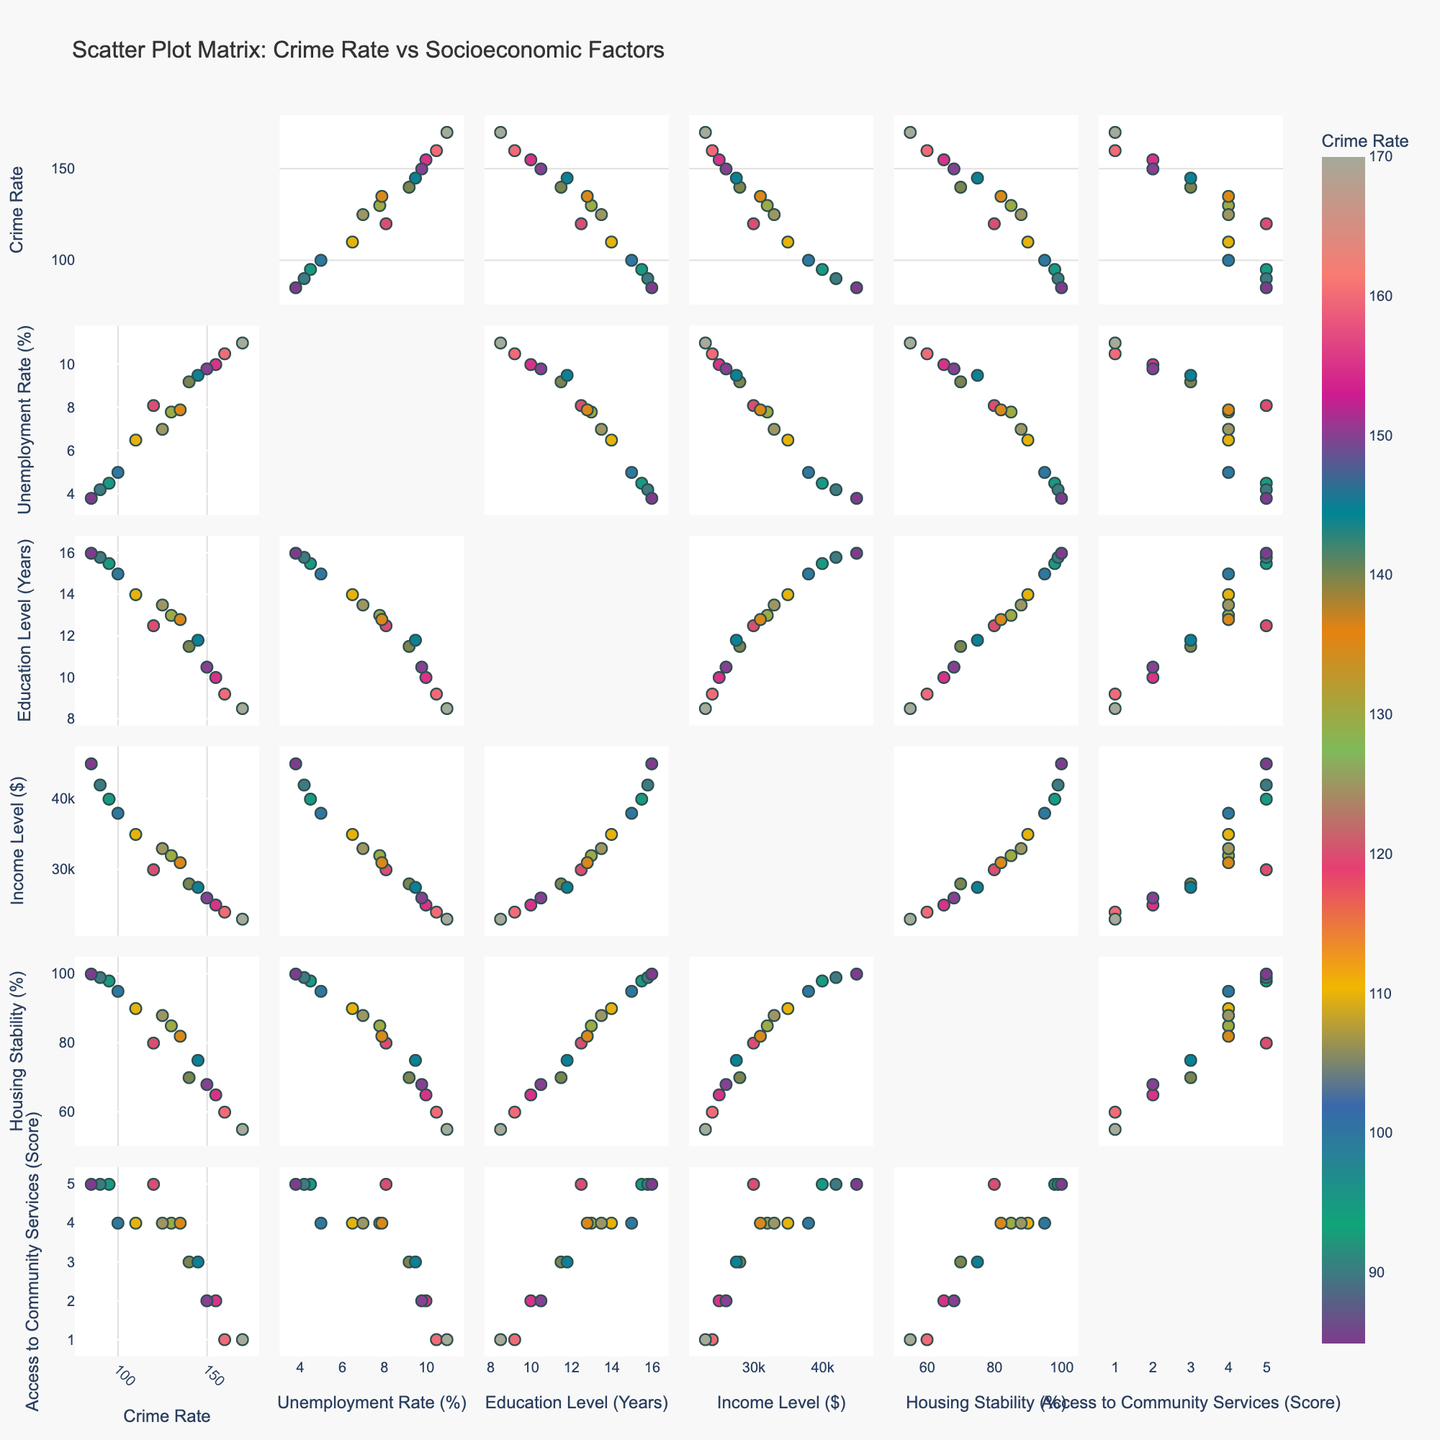What is the title of the figure? The title of the figure is displayed prominently at the top. It reads "Scatter Plot Matrix: Crime Rate vs Socioeconomic Factors".
Answer: Scatter Plot Matrix: Crime Rate vs Socioeconomic Factors Which socioeconomic factor has the lowest Crime Rate in the plot? By examining the scatter plots, the data point with the lowest Crime Rate is associated with the "Access to Community Services" factor, specifically when the score is 5.
Answer: Access to Community Services How many data points are there in the figure? The figure includes all data points from the dataset, which totals 15. Each plot contains the same 15 data points representing different socioeconomic factors.
Answer: 15 Compare the relationship between Crime Rate and Education Level. Is there a trend? To find the relationship, observe the scatter plot matrix cells intersecting between Crime Rate and Education Level. Higher education levels generally correspond to lower crime rates, suggesting an inverse relationship.
Answer: Inverse relationship What is the average Income Level for the top three highest Crime Rates? The top three highest Crime Rates are 170, 160, and 155. The respective Income Levels are $23,000, $24,000, and $25,000. The average is calculated as ($23,000 + $24,000 + $25,000) / 3 = $24,000.
Answer: $24,000 Which socioeconomic factor appears to have the strongest correlation with Crime Rate? By comparing scatter plots, "Unemployment Rate" shows the strongest visual correlation with Crime Rate. As Unemployment Rate increases, Crime Rate tends to be higher.
Answer: Unemployment Rate What is the median Housing Stability percentage for the dataset? To determine the median, list the Housing Stability values in ascending order: 55, 60, 65, 68, 70, 75, 80, 82, 85, 88, 90, 95, 98, 99, 100. The median value is the 8th value, which is 82%.
Answer: 82% How does Income Level compare between the highest and lowest Crime Rates? The highest Crime Rate of 170 corresponds to an Income Level of $23,000, and the lowest Crime Rate of 85 corresponds to an Income Level of $45,000.
Answer: Income Level is higher at lower Crime Rates Is there any socioeconomic factor where data points seem uniformly distributed with Crime Rates? Observing the scatter plots, "Access to Community Services" shows a relatively uniform distribution of data points across different Crime Rates without a strong discernable pattern.
Answer: Access to Community Services What can be inferred about the relationship between Housing Stability and Crime Rate? From the scatter plot matrix, it is apparent that higher Housing Stability percentages tend to align with lower Crime Rates, indicating a potential inverse relationship.
Answer: Inverse relationship 